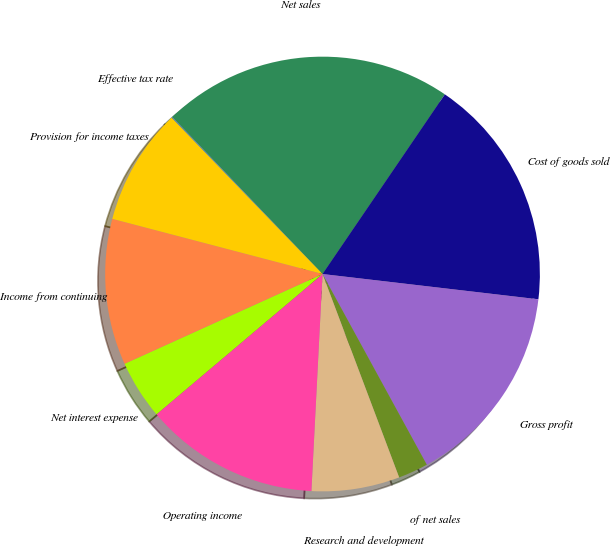Convert chart. <chart><loc_0><loc_0><loc_500><loc_500><pie_chart><fcel>Net sales<fcel>Cost of goods sold<fcel>Gross profit<fcel>of net sales<fcel>Research and development<fcel>Operating income<fcel>Net interest expense<fcel>Income from continuing<fcel>Provision for income taxes<fcel>Effective tax rate<nl><fcel>21.66%<fcel>17.34%<fcel>15.18%<fcel>2.23%<fcel>6.55%<fcel>13.02%<fcel>4.39%<fcel>10.86%<fcel>8.7%<fcel>0.07%<nl></chart> 